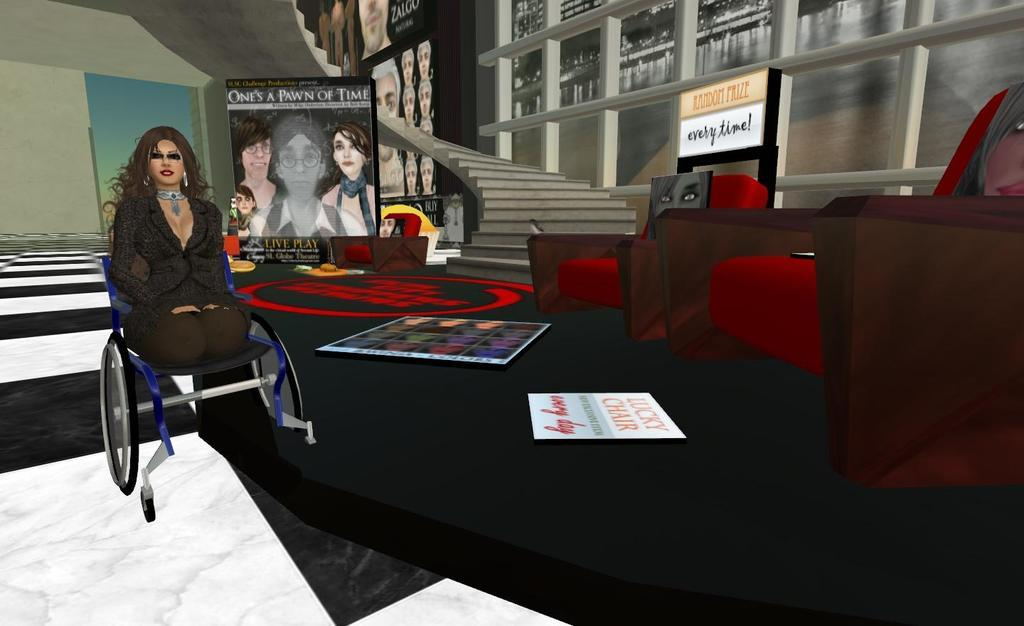What type of picture is the image? The image is an animated picture. What architectural feature can be seen in the image? There are stairs in the image. What objects are present in the image that can be used for sitting? There are chairs in the image. What is the person in the image using for mobility? There is a person sitting on a wheelchair in the image. What can be seen in the image that allows natural light to enter the space? There is a window in the image. What type of frame is visible around the snow in the image? There is no snow present in the image, and therefore no frame around it. 